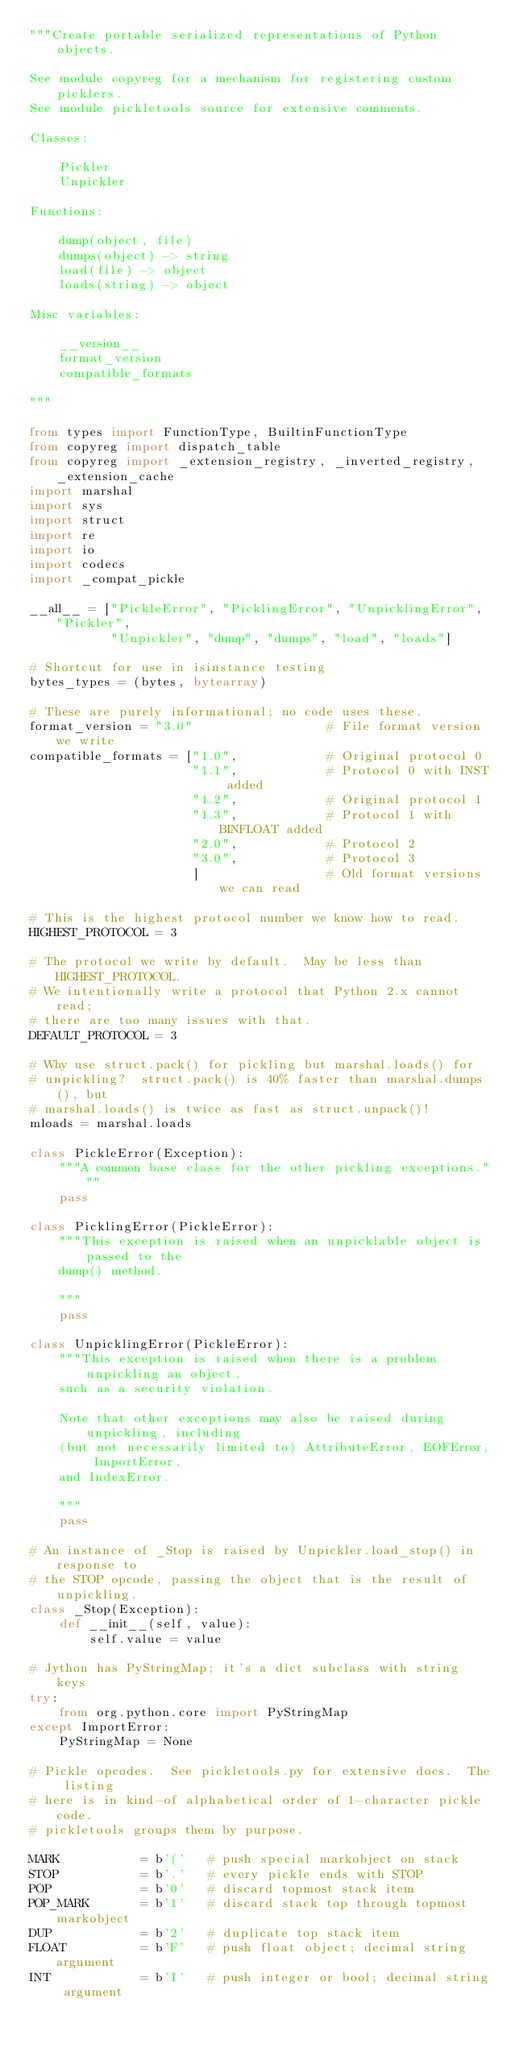<code> <loc_0><loc_0><loc_500><loc_500><_Python_>"""Create portable serialized representations of Python objects.

See module copyreg for a mechanism for registering custom picklers.
See module pickletools source for extensive comments.

Classes:

    Pickler
    Unpickler

Functions:

    dump(object, file)
    dumps(object) -> string
    load(file) -> object
    loads(string) -> object

Misc variables:

    __version__
    format_version
    compatible_formats

"""

from types import FunctionType, BuiltinFunctionType
from copyreg import dispatch_table
from copyreg import _extension_registry, _inverted_registry, _extension_cache
import marshal
import sys
import struct
import re
import io
import codecs
import _compat_pickle

__all__ = ["PickleError", "PicklingError", "UnpicklingError", "Pickler",
           "Unpickler", "dump", "dumps", "load", "loads"]

# Shortcut for use in isinstance testing
bytes_types = (bytes, bytearray)

# These are purely informational; no code uses these.
format_version = "3.0"                  # File format version we write
compatible_formats = ["1.0",            # Original protocol 0
                      "1.1",            # Protocol 0 with INST added
                      "1.2",            # Original protocol 1
                      "1.3",            # Protocol 1 with BINFLOAT added
                      "2.0",            # Protocol 2
                      "3.0",            # Protocol 3
                      ]                 # Old format versions we can read

# This is the highest protocol number we know how to read.
HIGHEST_PROTOCOL = 3

# The protocol we write by default.  May be less than HIGHEST_PROTOCOL.
# We intentionally write a protocol that Python 2.x cannot read;
# there are too many issues with that.
DEFAULT_PROTOCOL = 3

# Why use struct.pack() for pickling but marshal.loads() for
# unpickling?  struct.pack() is 40% faster than marshal.dumps(), but
# marshal.loads() is twice as fast as struct.unpack()!
mloads = marshal.loads

class PickleError(Exception):
    """A common base class for the other pickling exceptions."""
    pass

class PicklingError(PickleError):
    """This exception is raised when an unpicklable object is passed to the
    dump() method.

    """
    pass

class UnpicklingError(PickleError):
    """This exception is raised when there is a problem unpickling an object,
    such as a security violation.

    Note that other exceptions may also be raised during unpickling, including
    (but not necessarily limited to) AttributeError, EOFError, ImportError,
    and IndexError.

    """
    pass

# An instance of _Stop is raised by Unpickler.load_stop() in response to
# the STOP opcode, passing the object that is the result of unpickling.
class _Stop(Exception):
    def __init__(self, value):
        self.value = value

# Jython has PyStringMap; it's a dict subclass with string keys
try:
    from org.python.core import PyStringMap
except ImportError:
    PyStringMap = None

# Pickle opcodes.  See pickletools.py for extensive docs.  The listing
# here is in kind-of alphabetical order of 1-character pickle code.
# pickletools groups them by purpose.

MARK           = b'('   # push special markobject on stack
STOP           = b'.'   # every pickle ends with STOP
POP            = b'0'   # discard topmost stack item
POP_MARK       = b'1'   # discard stack top through topmost markobject
DUP            = b'2'   # duplicate top stack item
FLOAT          = b'F'   # push float object; decimal string argument
INT            = b'I'   # push integer or bool; decimal string argument</code> 